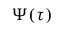Convert formula to latex. <formula><loc_0><loc_0><loc_500><loc_500>\Psi ( \tau )</formula> 